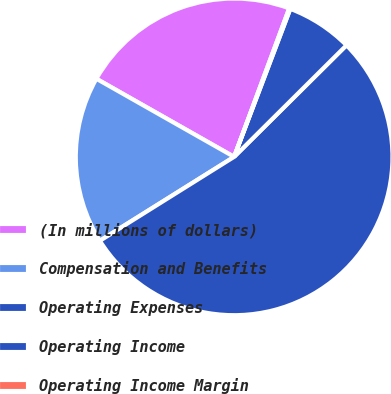Convert chart. <chart><loc_0><loc_0><loc_500><loc_500><pie_chart><fcel>(In millions of dollars)<fcel>Compensation and Benefits<fcel>Operating Expenses<fcel>Operating Income<fcel>Operating Income Margin<nl><fcel>22.44%<fcel>17.1%<fcel>53.55%<fcel>6.78%<fcel>0.12%<nl></chart> 